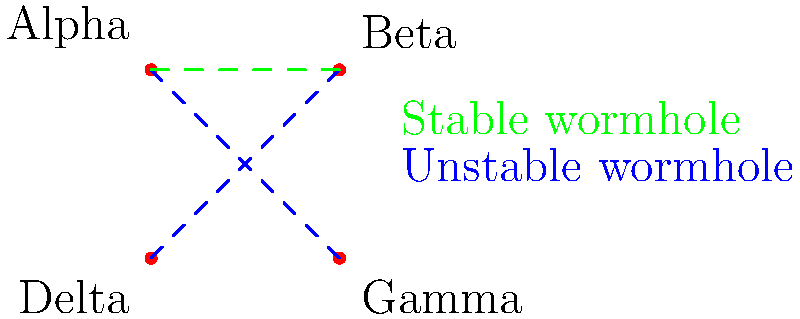In the Star Trek universe, wormholes connect different quadrants of the Milky Way galaxy. Based on the topology shown in the diagram, which quadrant has the most direct wormhole connections, and what does this imply for interstellar travel and exploration? To answer this question, we need to analyze the wormhole connections between the quadrants:

1. Identify the connections:
   - Alpha to Gamma (unstable)
   - Beta to Delta (unstable)
   - Alpha to Beta (stable)

2. Count the connections for each quadrant:
   - Alpha: 2 connections (to Gamma and Beta)
   - Beta: 2 connections (to Alpha and Delta)
   - Gamma: 1 connection (to Alpha)
   - Delta: 1 connection (to Beta)

3. Determine the quadrant with the most connections:
   Both Alpha and Beta have 2 connections, while Gamma and Delta have only 1 each.

4. Implications for interstellar travel and exploration:
   - The Alpha Quadrant has the most strategic position, with direct access to both Beta (stable) and Gamma (unstable) Quadrants.
   - This topology allows for easier exploration and communication between Alpha, Beta, and Gamma Quadrants.
   - The stable wormhole between Alpha and Beta suggests a reliable route for regular travel and trade.
   - Gamma and Delta Quadrants are more isolated, requiring passage through other quadrants for full galaxy exploration.
   - The unstable nature of some wormholes implies potential risks and unpredictability in long-distance travel.

5. In Star Trek lore, this topology aligns with the Federation's (based in Alpha Quadrant) ability to explore and interact with various species across different quadrants, while also explaining the challenges faced in reaching the more distant Gamma and Delta Quadrants.
Answer: Alpha Quadrant; strategic advantage for exploration and communication across multiple quadrants. 